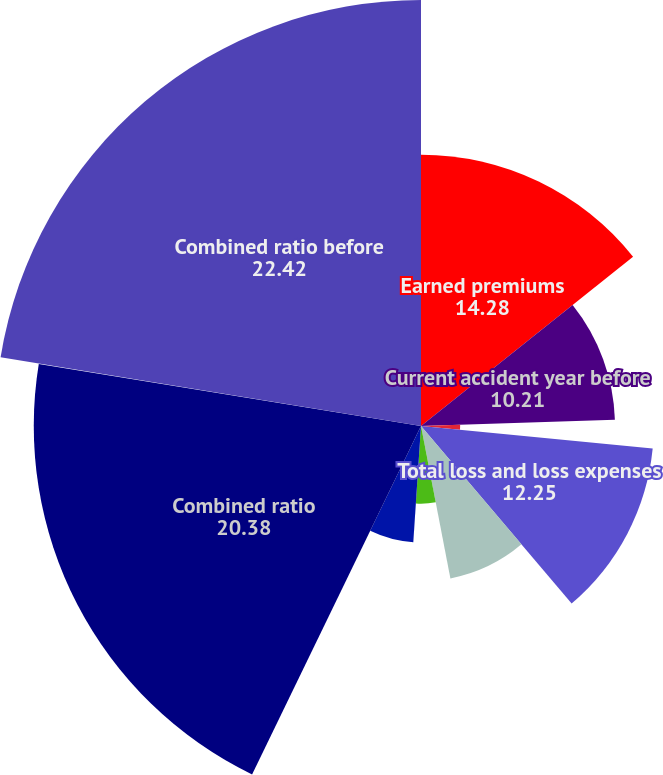Convert chart. <chart><loc_0><loc_0><loc_500><loc_500><pie_chart><fcel>Earned premiums<fcel>Current accident year before<fcel>Current accident year<fcel>Total loss and loss expenses<fcel>Underwriting expenses<fcel>Prior accident years before<fcel>Prior accident years<fcel>Combined ratio<fcel>Contribution from catastrophe<fcel>Combined ratio before<nl><fcel>14.28%<fcel>10.21%<fcel>2.06%<fcel>12.25%<fcel>8.17%<fcel>4.09%<fcel>6.13%<fcel>20.38%<fcel>0.02%<fcel>22.42%<nl></chart> 